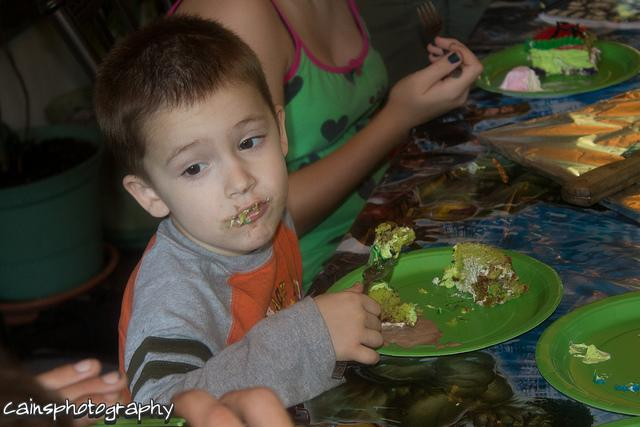If the boy overeats he will get what kind of body ache? Please explain your reasoning. stomach. The boy is eating a lot of cake that will give him a stomachache if he eats too much 